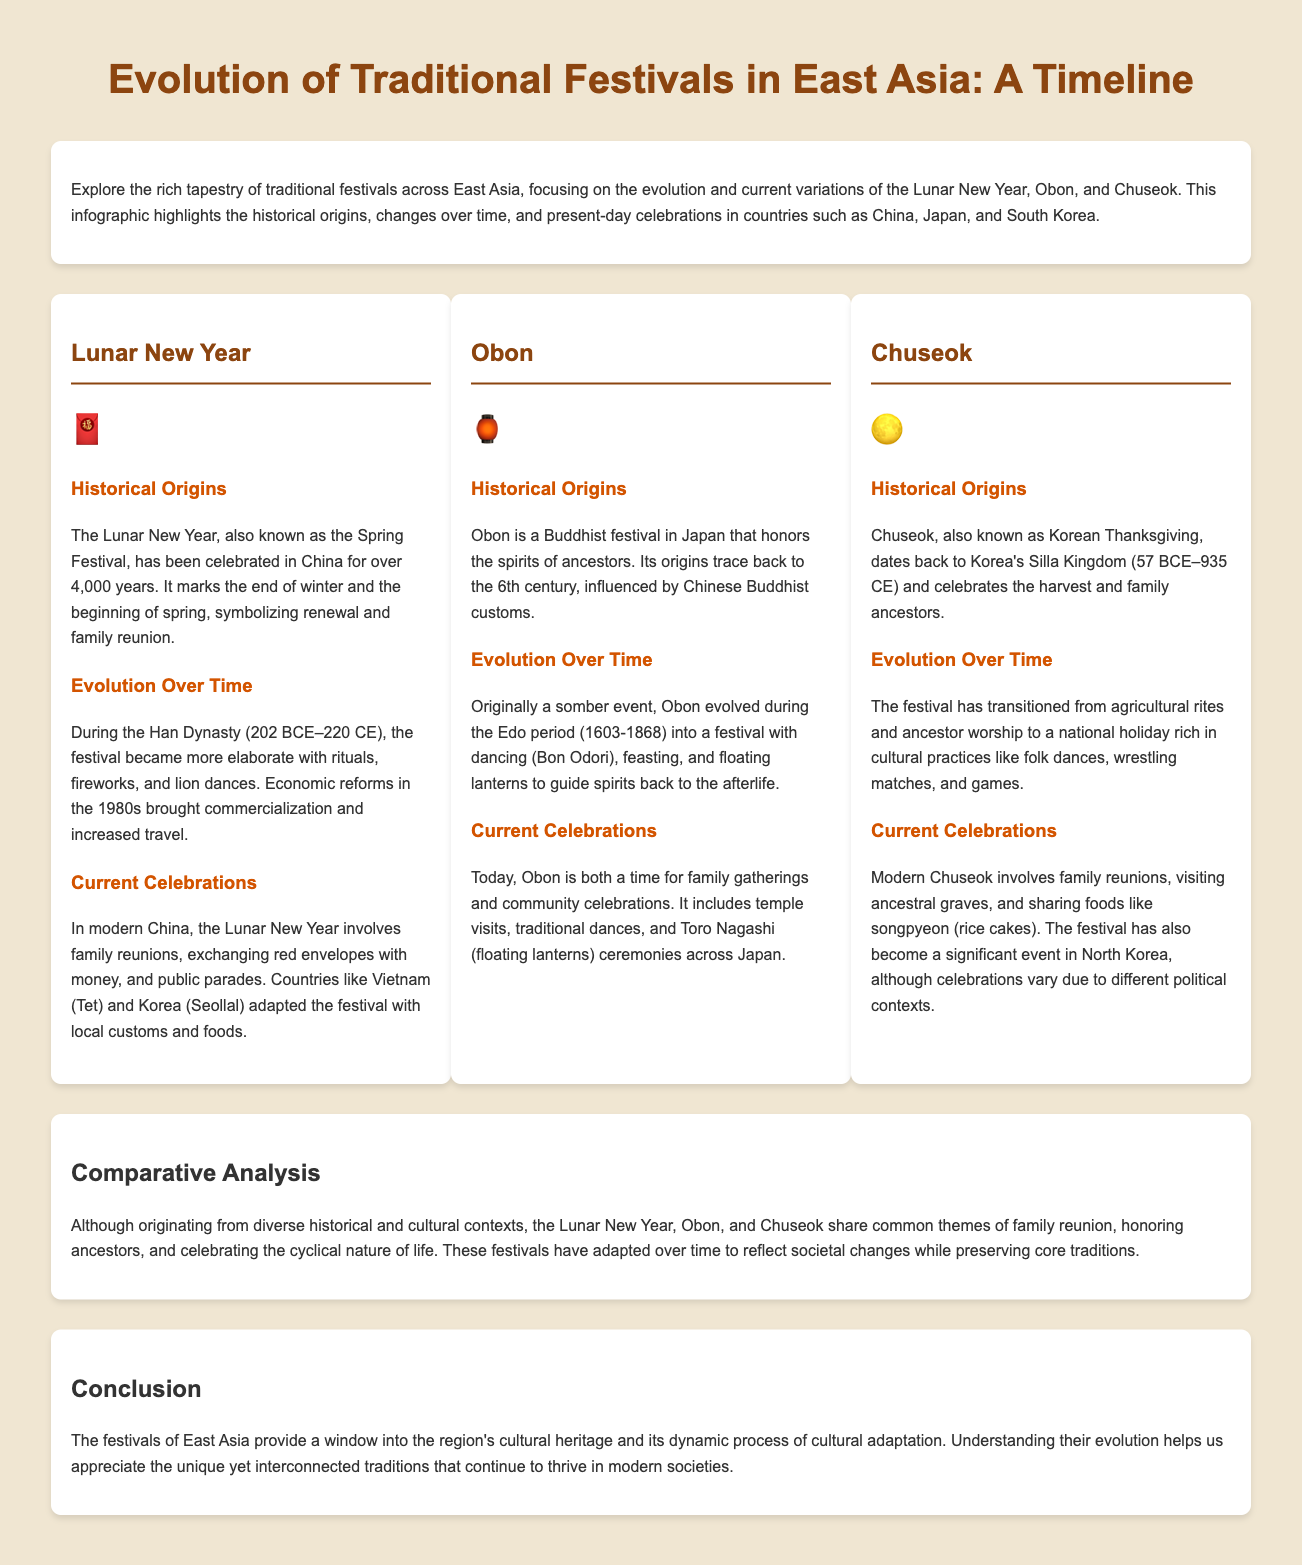what is the historical origin of the Lunar New Year? The document states that the Lunar New Year has been celebrated in China for over 4,000 years, marking the end of winter and the beginning of spring.
Answer: over 4,000 years what does Obon honor? The document mentions that Obon honors the spirits of ancestors.
Answer: ancestors during which period did Obon evolve into a festival with dancing? The document indicates that Obon evolved during the Edo period (1603-1868).
Answer: Edo period (1603-1868) what is the main shared theme among the festivals discussed? The document highlights that the festivals share common themes of family reunion, honoring ancestors, and celebrating the cyclical nature of life.
Answer: family reunion, honoring ancestors, cyclical nature of life what type of festival is Chuseok commonly referred to as? The document refers to Chuseok as Korean Thanksgiving.
Answer: Korean Thanksgiving how long has Obon been celebrated? The document states its origins trace back to the 6th century.
Answer: 6th century which symbol represents the Lunar New Year in the document? The document features the emoji 🧧 for the Lunar New Year.
Answer: 🧧 what food is traditionally shared during Chuseok? The document notes that songpyeon (rice cakes) is shared during Chuseok.
Answer: songpyeon (rice cakes) 